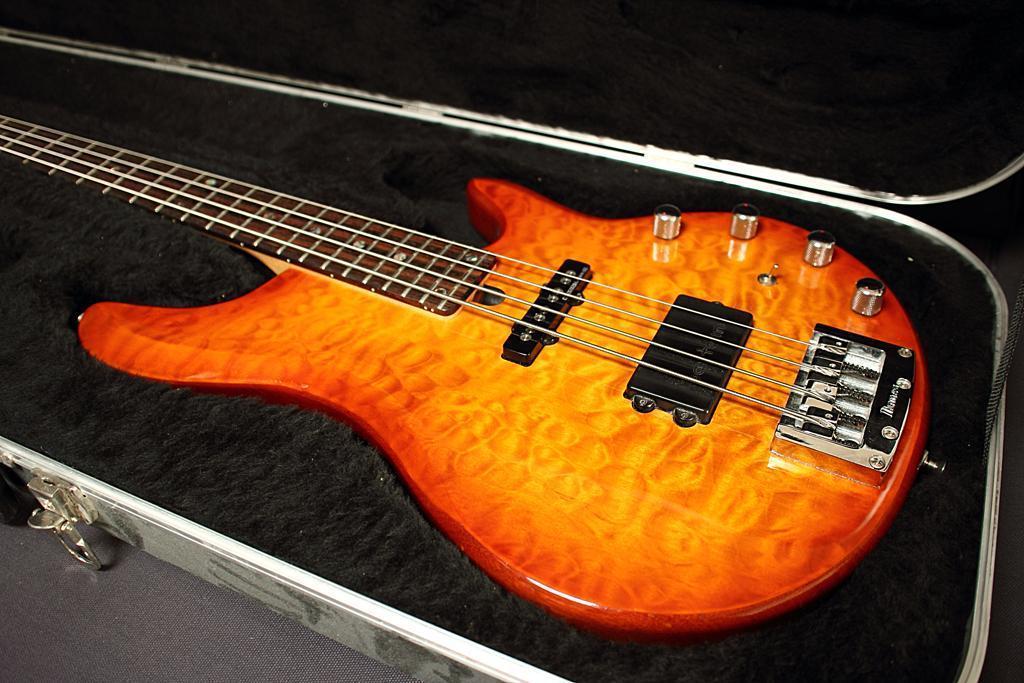Can you describe this image briefly? In this image there is one guitar and one box is there on the floor. 